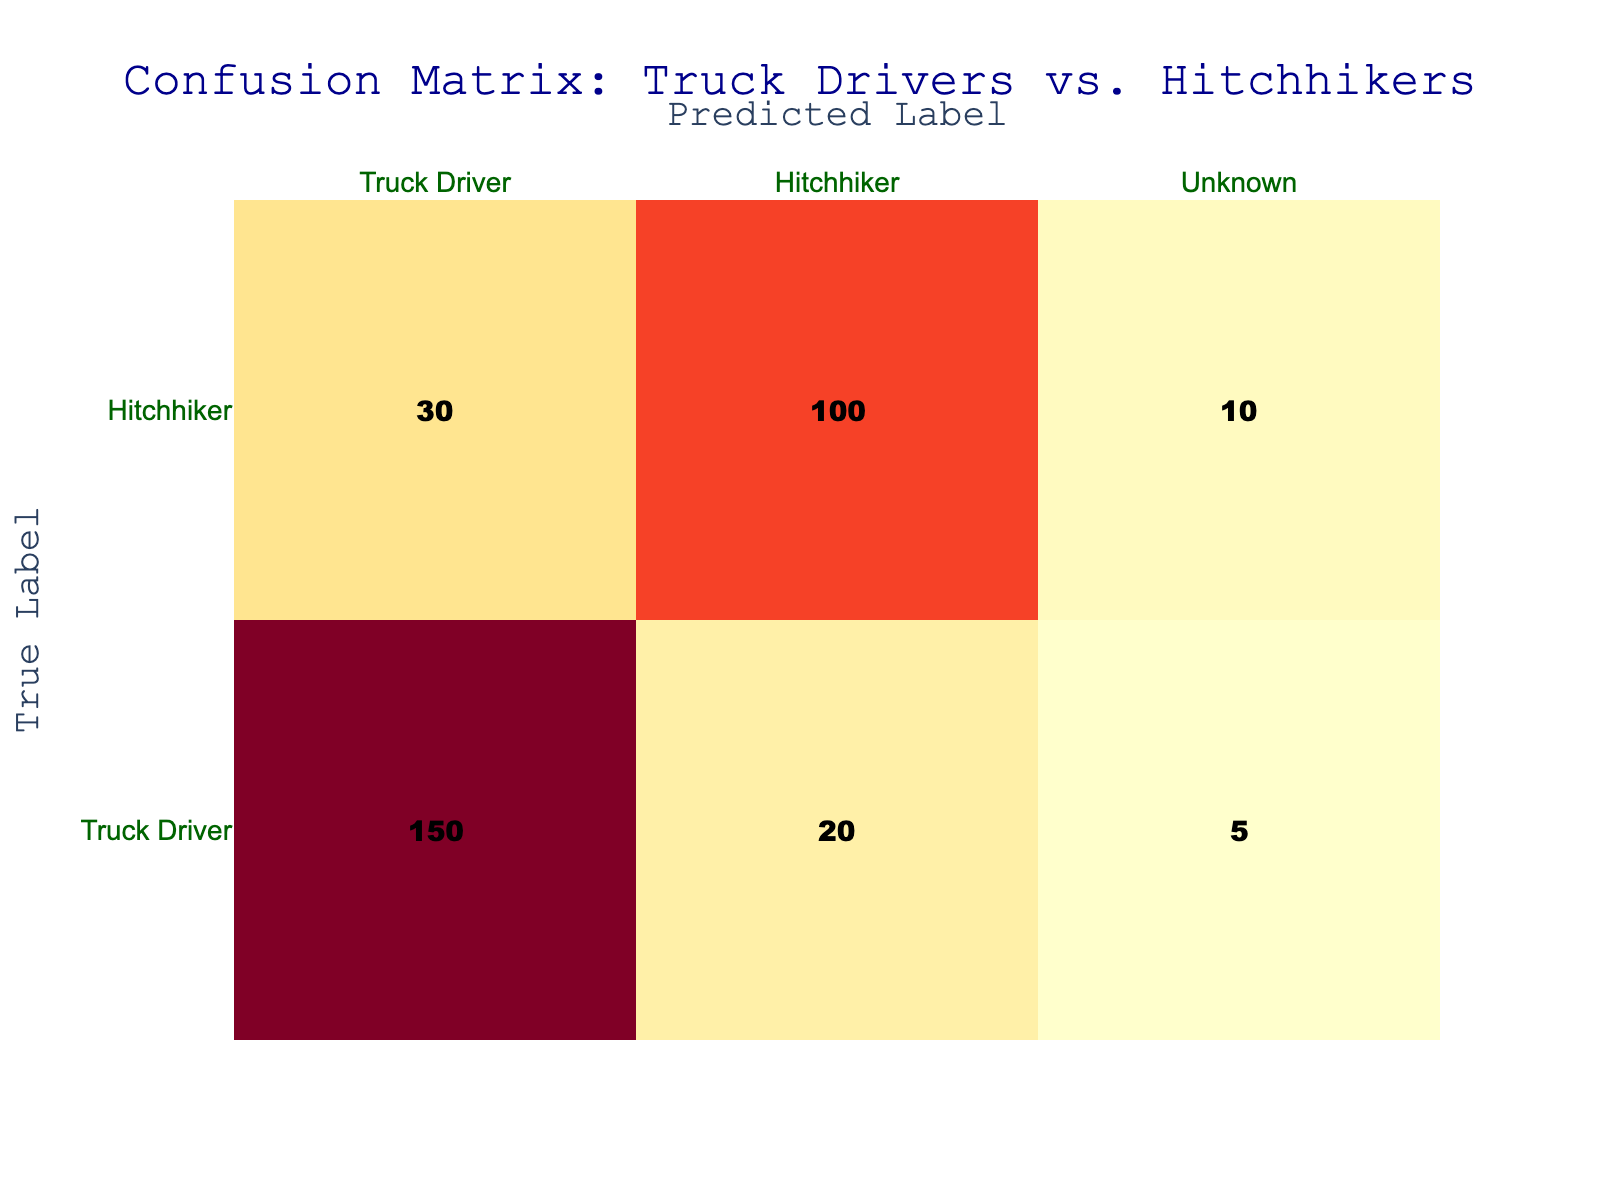What is the count of true Truck Drivers predicted correctly? The confusion matrix shows the count of true Truck Drivers predicted correctly in the cell corresponding to "Truck Driver" under "Truck Driver", which is 150.
Answer: 150 How many Hitchhikers were mistakenly identified as Truck Drivers? We look at the predicted label "Truck Driver" and find the true label "Hitchhiker", which indicates a count of 30.
Answer: 30 What is the total count of Hitchhikers predicted correctly? The count of Hitchhikers predicted correctly is in the cell labeled "Hitchhiker" under "Hitchhiker", which is 100. Therefore, there's only one value to consider.
Answer: 100 Are there more Truck Drivers than Hitchhikers in the dataset? To answer this, we can sum the counts of true Truck Drivers (150 + 20 + 5) and compare it to the total counts of true Hitchhikers (30 + 100 + 10). Truck Drivers total 175 while Hitchhikers total 140; thus, there are more Truck Drivers.
Answer: Yes What is the total number of observations for Truck Drivers? We sum the counts of all cells corresponding to the true label "Truck Driver": (150 + 20 + 5). Calculating this gives us 175 Truck Drivers in total.
Answer: 175 What is the percentage of Hitchhikers that were correctly identified out of all Hitchhikers encountered? The correctly identified Hitchhikers are 100, and the total encountered are (30 + 100 + 10), which sums up to 140. The percentage is (100 / 140) * 100 = approximately 71.43%.
Answer: Approximately 71.43% How many Unknown identities were predicted? We look at the total counts under the "Unknown" predicted label, adding the counts for Truck Drivers (5) and Hitchhikers (10) gives us 15.
Answer: 15 What is the difference between the count of true Truck Drivers and true Hitchhikers? The count of true Truck Drivers is 175 (sum of 150, 20, and 5) and true Hitchhikers is 140 (sum of 30, 100, and 10). Calculating the difference gives us 175 - 140 = 35.
Answer: 35 What percentage of Truck Drivers were incorrectly identified as Hitchhikers? The count of true Truck Drivers is 175, and the count of Truck Drivers incorrectly labeled as Hitchhikers is 20. The percentage is calculated as (20 / 175) * 100, which is approximately 11.43%.
Answer: Approximately 11.43% 